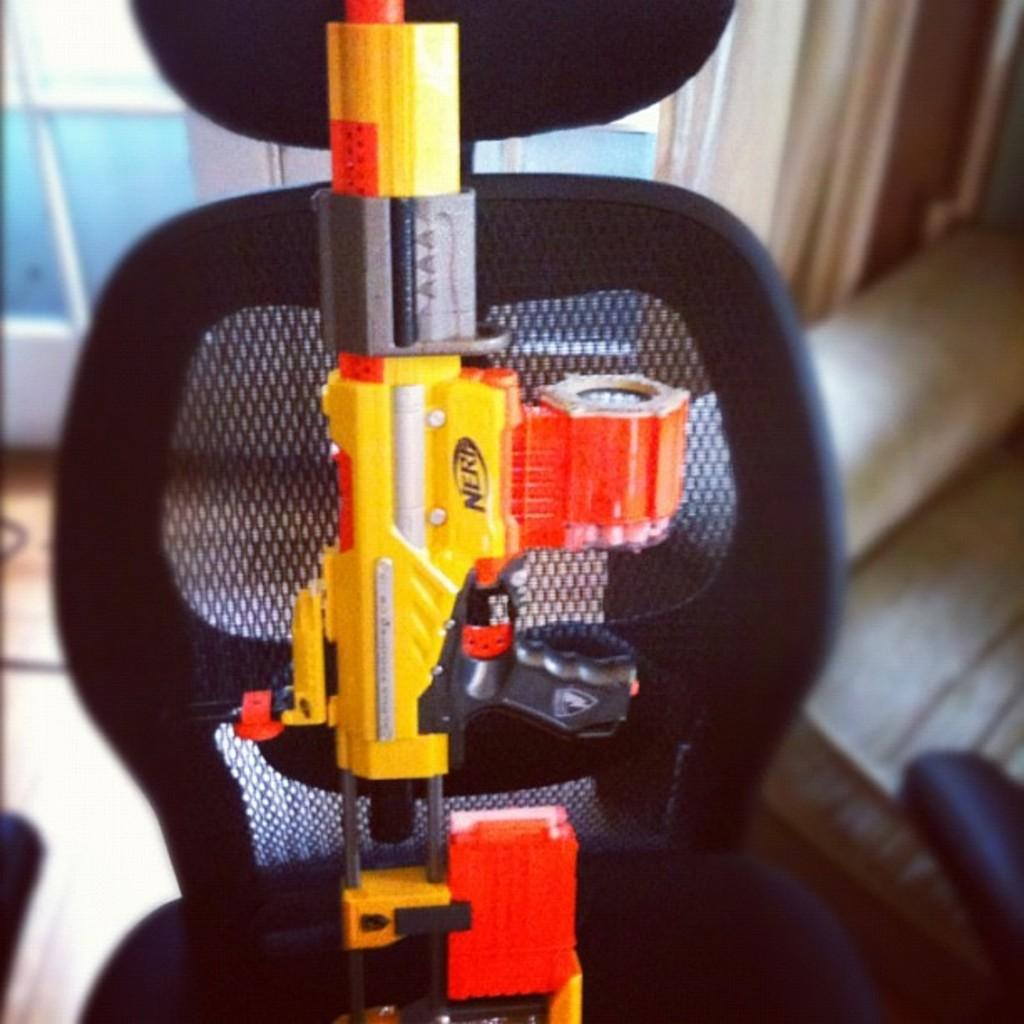What object is the main focus of the image? There is a gun in the image. Where is the gun placed? The gun is on a black color chair. Can you describe the background of the image? The background of the image is blurred. What type of bells can be heard ringing in the image? There are no bells present in the image, and therefore no sound can be heard. 